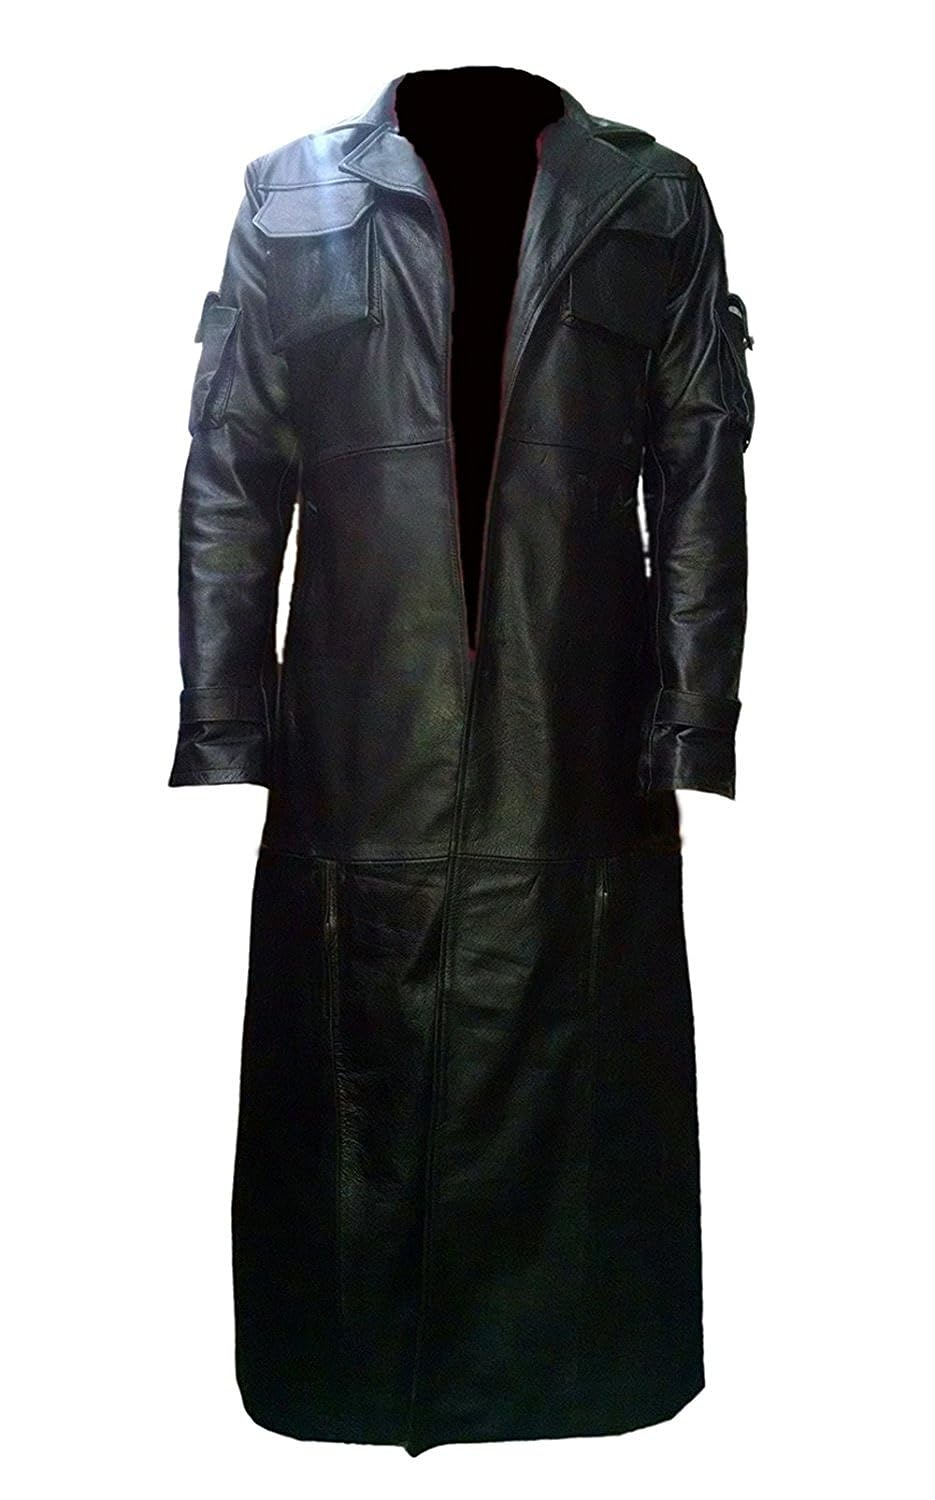How does the design of the coat's collar contribute to its overall aesthetic, and what function might it serve? The high, upright collar of the coat creates a bold and dramatic visual accent, enhancing the garment's aesthetic by imparting a sense of authority and mystery, often seen in gothic or dystopian styles. This design isn't just for show; the collar serves a functional purpose by providing substantial neck coverage that helps shield against wind and cold, important in harsh weather. Additionally, its reinforced structure could be crucial for maintaining a specific silhouette, crucial in thematic or historical costumes where detail fidelity is key. 